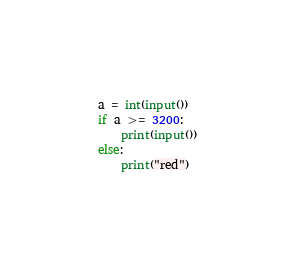<code> <loc_0><loc_0><loc_500><loc_500><_Python_>a = int(input())
if a >= 3200:
    print(input())
else:
    print("red")</code> 